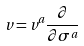<formula> <loc_0><loc_0><loc_500><loc_500>v = v ^ { a } \frac { \partial } { \partial \sigma ^ { a } }</formula> 